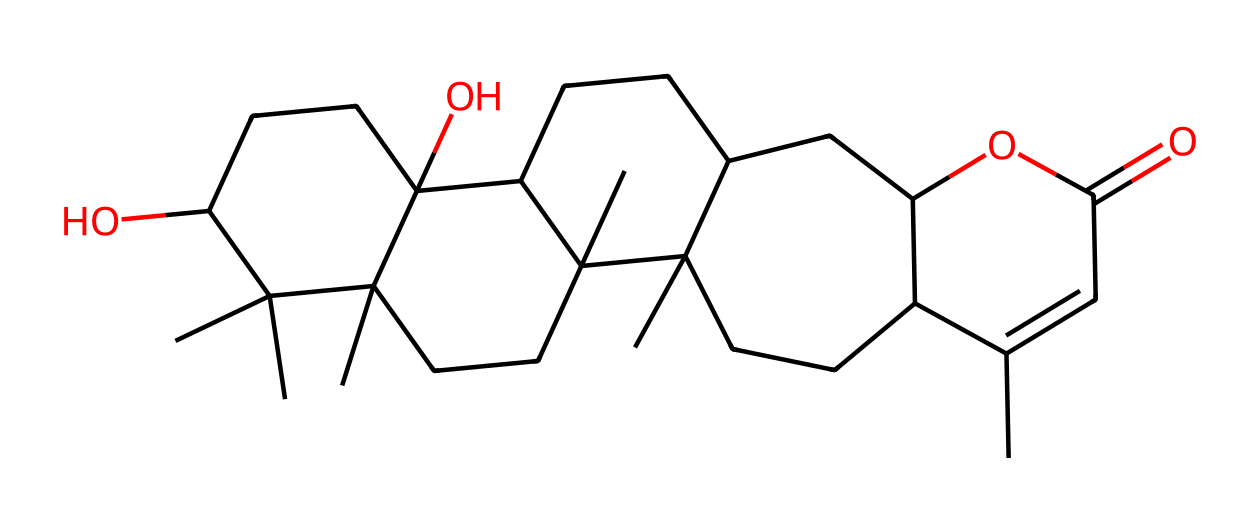What is the molecular formula for this compound? To determine the molecular formula, we need to analyze the SMILES structure to count each type of atom present. From the SMILES, we can deduce there are a total of 30 carbon atoms, 46 hydrogen atoms, and 6 oxygen atoms, so the molecular formula is C30H46O6.
Answer: C30H46O6 How many oxygen atoms are in this structure? By examining the SMILES format, we can see that there are 6 oxygen atoms present in the structure. Each 'O' in the SMILES indicates the presence of an oxygen atom.
Answer: 6 What type of compound is this molecule primarily classified as? Given that the SMILES structure indicates a combination of cyclic and acyclic structures with an ester and hydroxyl functional groups, this compound can be categorized as a sesquiterpenoid, which are common in flavors and fragrances.
Answer: sesquiterpenoid Does this molecule contain any functional groups? Yes, upon analyzing the SMILES, we can identify the presence of functional groups such as alcohol (-OH) and ester (-COO-) groups, which are crucial in determining the properties of the compound and its potential as a fragrance.
Answer: alcohol, ester What is the significance of this molecule being part of valerian root extract? This molecule is known for its sedative properties, which are linked to its molecular interactions in the nervous system. Valerian root extract is commonly used for its calming effects, making this molecular structure significant for alternative sleep solutions.
Answer: sedative properties 